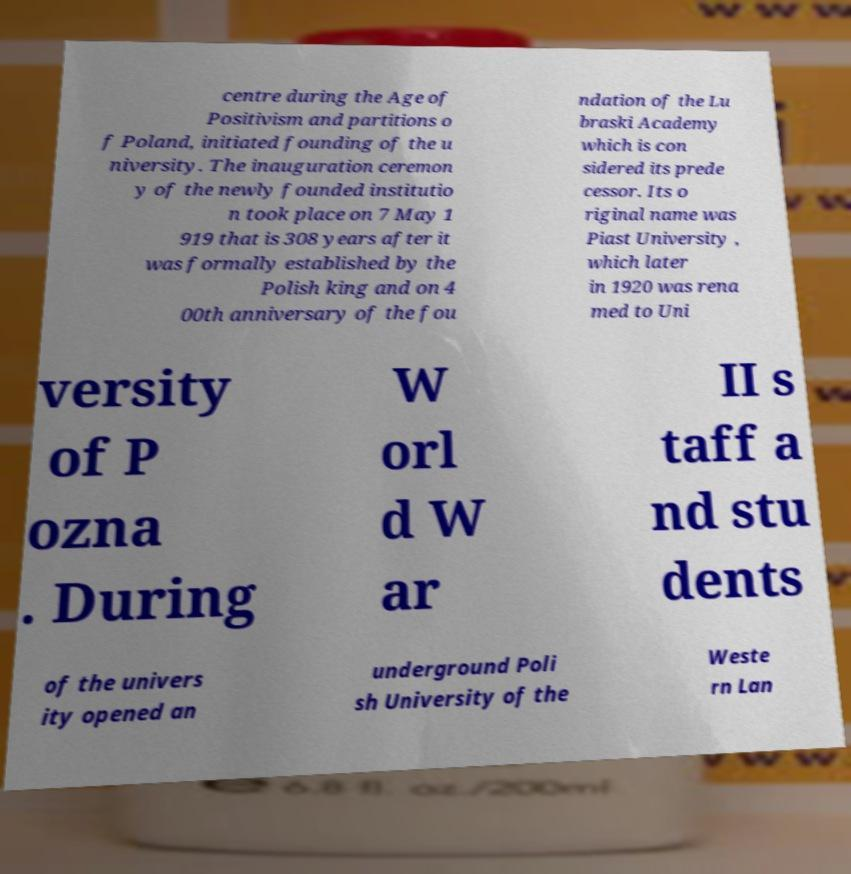Can you accurately transcribe the text from the provided image for me? centre during the Age of Positivism and partitions o f Poland, initiated founding of the u niversity. The inauguration ceremon y of the newly founded institutio n took place on 7 May 1 919 that is 308 years after it was formally established by the Polish king and on 4 00th anniversary of the fou ndation of the Lu braski Academy which is con sidered its prede cessor. Its o riginal name was Piast University , which later in 1920 was rena med to Uni versity of P ozna . During W orl d W ar II s taff a nd stu dents of the univers ity opened an underground Poli sh University of the Weste rn Lan 